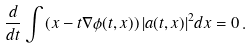<formula> <loc_0><loc_0><loc_500><loc_500>\frac { d } { d t } \int \left ( x - t \nabla \phi ( t , x ) \right ) | a ( t , x ) | ^ { 2 } d x = 0 \, .</formula> 